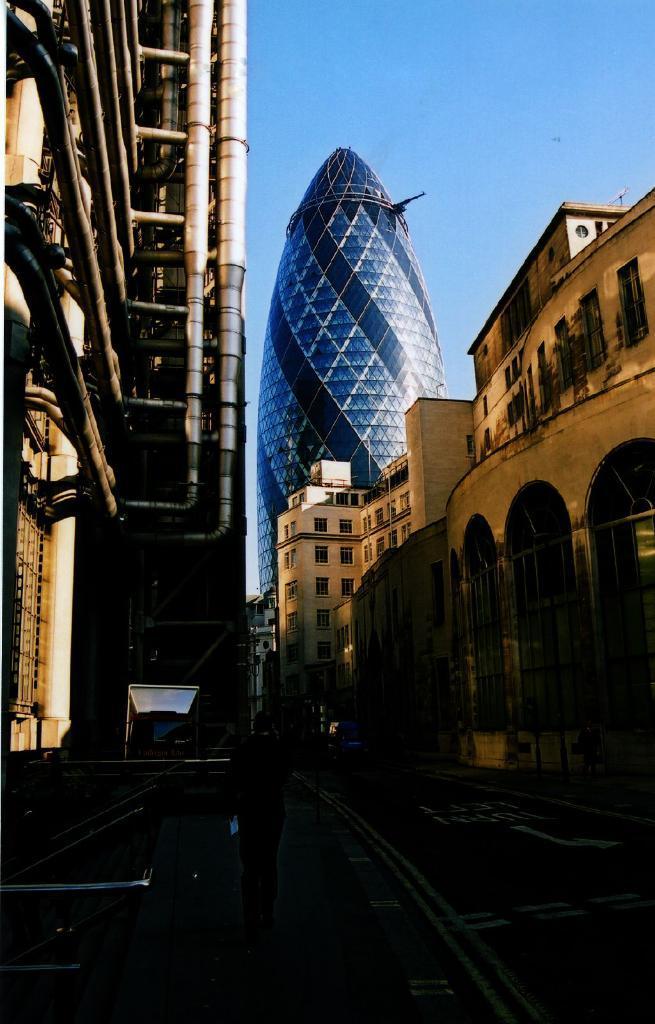Describe this image in one or two sentences. In this image there is the sky, there are buildings, there is a building truncated towards the right of the image, there is the road, there is a person walking on the road, there is a person holding an object, there is a building truncated towards the left of the image, there is an object truncated towards the left of the image, there are pipes. 